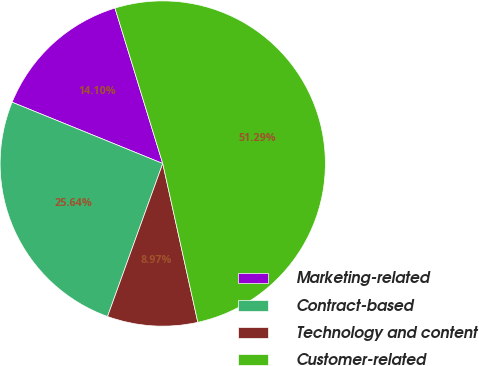Convert chart to OTSL. <chart><loc_0><loc_0><loc_500><loc_500><pie_chart><fcel>Marketing-related<fcel>Contract-based<fcel>Technology and content<fcel>Customer-related<nl><fcel>14.1%<fcel>25.64%<fcel>8.97%<fcel>51.28%<nl></chart> 